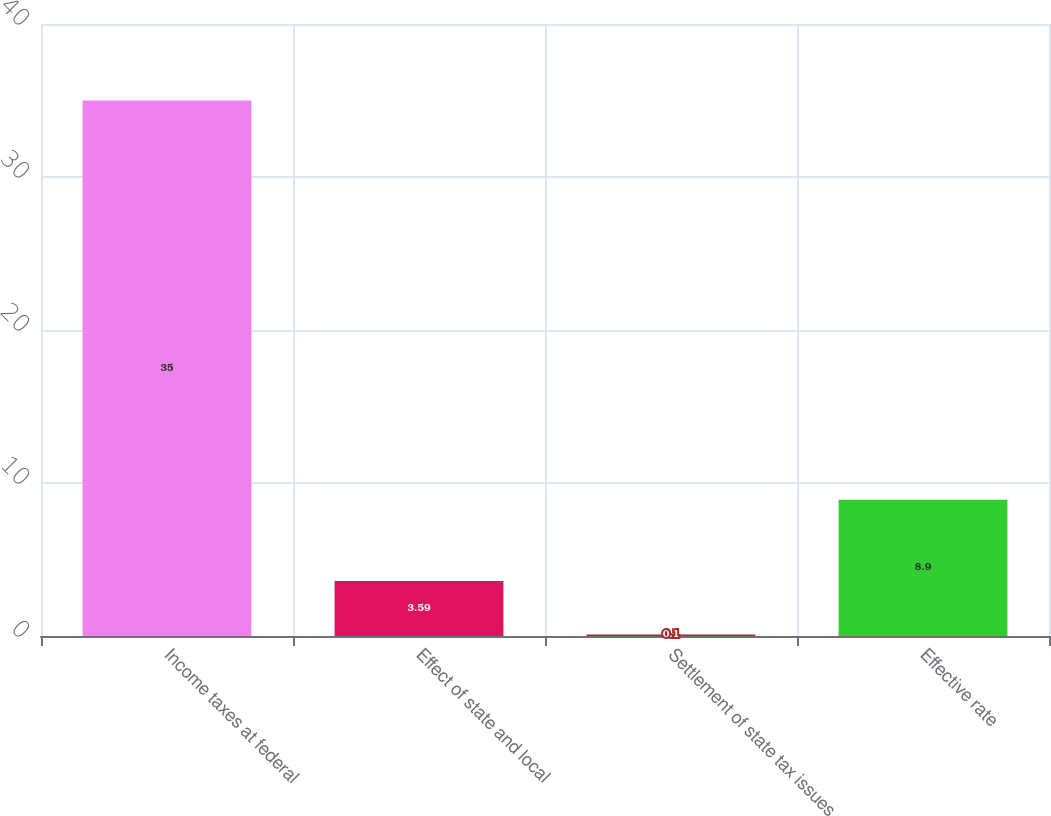Convert chart. <chart><loc_0><loc_0><loc_500><loc_500><bar_chart><fcel>Income taxes at federal<fcel>Effect of state and local<fcel>Settlement of state tax issues<fcel>Effective rate<nl><fcel>35<fcel>3.59<fcel>0.1<fcel>8.9<nl></chart> 